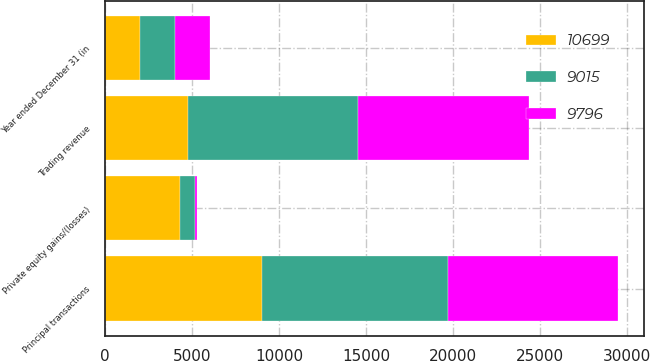Convert chart to OTSL. <chart><loc_0><loc_0><loc_500><loc_500><stacked_bar_chart><ecel><fcel>Year ended December 31 (in<fcel>Trading revenue<fcel>Private equity gains/(losses)<fcel>Principal transactions<nl><fcel>9796<fcel>2009<fcel>9870<fcel>74<fcel>9796<nl><fcel>9015<fcel>2008<fcel>9791<fcel>908<fcel>10699<nl><fcel>10699<fcel>2007<fcel>4736<fcel>4279<fcel>9015<nl></chart> 